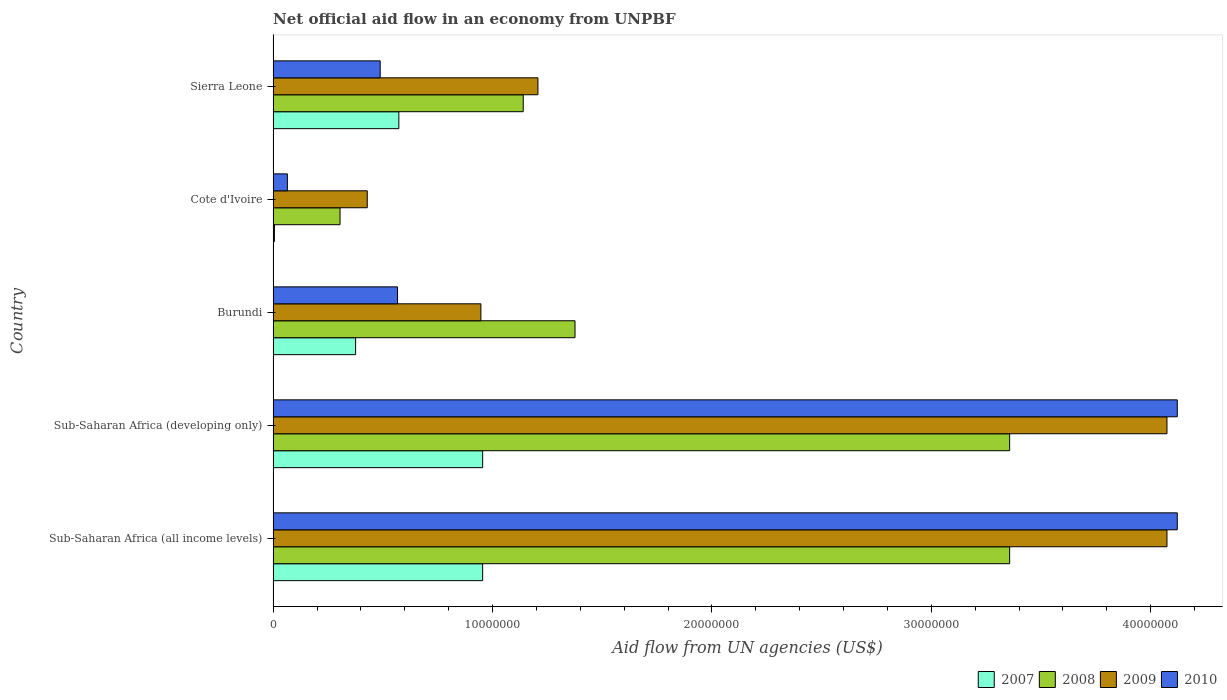How many different coloured bars are there?
Make the answer very short. 4. How many groups of bars are there?
Ensure brevity in your answer.  5. Are the number of bars per tick equal to the number of legend labels?
Your answer should be compact. Yes. Are the number of bars on each tick of the Y-axis equal?
Your answer should be very brief. Yes. How many bars are there on the 2nd tick from the top?
Provide a succinct answer. 4. What is the label of the 2nd group of bars from the top?
Your response must be concise. Cote d'Ivoire. What is the net official aid flow in 2008 in Sierra Leone?
Provide a succinct answer. 1.14e+07. Across all countries, what is the maximum net official aid flow in 2007?
Ensure brevity in your answer.  9.55e+06. Across all countries, what is the minimum net official aid flow in 2007?
Your answer should be compact. 6.00e+04. In which country was the net official aid flow in 2007 maximum?
Make the answer very short. Sub-Saharan Africa (all income levels). In which country was the net official aid flow in 2009 minimum?
Ensure brevity in your answer.  Cote d'Ivoire. What is the total net official aid flow in 2008 in the graph?
Keep it short and to the point. 9.54e+07. What is the difference between the net official aid flow in 2009 in Sierra Leone and that in Sub-Saharan Africa (all income levels)?
Give a very brief answer. -2.87e+07. What is the difference between the net official aid flow in 2008 in Sub-Saharan Africa (developing only) and the net official aid flow in 2009 in Cote d'Ivoire?
Make the answer very short. 2.93e+07. What is the average net official aid flow in 2010 per country?
Offer a very short reply. 1.87e+07. What is the difference between the net official aid flow in 2009 and net official aid flow in 2008 in Sub-Saharan Africa (all income levels)?
Ensure brevity in your answer.  7.17e+06. What is the ratio of the net official aid flow in 2010 in Burundi to that in Sub-Saharan Africa (all income levels)?
Offer a very short reply. 0.14. What is the difference between the highest and the lowest net official aid flow in 2009?
Offer a terse response. 3.64e+07. In how many countries, is the net official aid flow in 2009 greater than the average net official aid flow in 2009 taken over all countries?
Give a very brief answer. 2. Is the sum of the net official aid flow in 2009 in Cote d'Ivoire and Sub-Saharan Africa (developing only) greater than the maximum net official aid flow in 2008 across all countries?
Give a very brief answer. Yes. Is it the case that in every country, the sum of the net official aid flow in 2010 and net official aid flow in 2007 is greater than the sum of net official aid flow in 2009 and net official aid flow in 2008?
Your answer should be very brief. No. What does the 4th bar from the top in Sub-Saharan Africa (developing only) represents?
Your answer should be very brief. 2007. Are all the bars in the graph horizontal?
Make the answer very short. Yes. How many countries are there in the graph?
Provide a succinct answer. 5. Are the values on the major ticks of X-axis written in scientific E-notation?
Offer a terse response. No. Does the graph contain grids?
Offer a terse response. No. Where does the legend appear in the graph?
Your response must be concise. Bottom right. How are the legend labels stacked?
Offer a very short reply. Horizontal. What is the title of the graph?
Keep it short and to the point. Net official aid flow in an economy from UNPBF. Does "1964" appear as one of the legend labels in the graph?
Provide a short and direct response. No. What is the label or title of the X-axis?
Keep it short and to the point. Aid flow from UN agencies (US$). What is the Aid flow from UN agencies (US$) in 2007 in Sub-Saharan Africa (all income levels)?
Ensure brevity in your answer.  9.55e+06. What is the Aid flow from UN agencies (US$) of 2008 in Sub-Saharan Africa (all income levels)?
Ensure brevity in your answer.  3.36e+07. What is the Aid flow from UN agencies (US$) of 2009 in Sub-Saharan Africa (all income levels)?
Provide a succinct answer. 4.07e+07. What is the Aid flow from UN agencies (US$) in 2010 in Sub-Saharan Africa (all income levels)?
Make the answer very short. 4.12e+07. What is the Aid flow from UN agencies (US$) in 2007 in Sub-Saharan Africa (developing only)?
Your answer should be very brief. 9.55e+06. What is the Aid flow from UN agencies (US$) in 2008 in Sub-Saharan Africa (developing only)?
Make the answer very short. 3.36e+07. What is the Aid flow from UN agencies (US$) of 2009 in Sub-Saharan Africa (developing only)?
Keep it short and to the point. 4.07e+07. What is the Aid flow from UN agencies (US$) of 2010 in Sub-Saharan Africa (developing only)?
Provide a short and direct response. 4.12e+07. What is the Aid flow from UN agencies (US$) in 2007 in Burundi?
Give a very brief answer. 3.76e+06. What is the Aid flow from UN agencies (US$) of 2008 in Burundi?
Give a very brief answer. 1.38e+07. What is the Aid flow from UN agencies (US$) in 2009 in Burundi?
Offer a terse response. 9.47e+06. What is the Aid flow from UN agencies (US$) in 2010 in Burundi?
Keep it short and to the point. 5.67e+06. What is the Aid flow from UN agencies (US$) in 2008 in Cote d'Ivoire?
Offer a very short reply. 3.05e+06. What is the Aid flow from UN agencies (US$) of 2009 in Cote d'Ivoire?
Ensure brevity in your answer.  4.29e+06. What is the Aid flow from UN agencies (US$) in 2010 in Cote d'Ivoire?
Make the answer very short. 6.50e+05. What is the Aid flow from UN agencies (US$) of 2007 in Sierra Leone?
Your answer should be very brief. 5.73e+06. What is the Aid flow from UN agencies (US$) in 2008 in Sierra Leone?
Give a very brief answer. 1.14e+07. What is the Aid flow from UN agencies (US$) of 2009 in Sierra Leone?
Provide a succinct answer. 1.21e+07. What is the Aid flow from UN agencies (US$) in 2010 in Sierra Leone?
Offer a terse response. 4.88e+06. Across all countries, what is the maximum Aid flow from UN agencies (US$) in 2007?
Your answer should be compact. 9.55e+06. Across all countries, what is the maximum Aid flow from UN agencies (US$) of 2008?
Give a very brief answer. 3.36e+07. Across all countries, what is the maximum Aid flow from UN agencies (US$) of 2009?
Provide a succinct answer. 4.07e+07. Across all countries, what is the maximum Aid flow from UN agencies (US$) of 2010?
Your response must be concise. 4.12e+07. Across all countries, what is the minimum Aid flow from UN agencies (US$) in 2008?
Provide a short and direct response. 3.05e+06. Across all countries, what is the minimum Aid flow from UN agencies (US$) of 2009?
Your answer should be compact. 4.29e+06. Across all countries, what is the minimum Aid flow from UN agencies (US$) of 2010?
Your answer should be compact. 6.50e+05. What is the total Aid flow from UN agencies (US$) in 2007 in the graph?
Offer a very short reply. 2.86e+07. What is the total Aid flow from UN agencies (US$) of 2008 in the graph?
Offer a terse response. 9.54e+07. What is the total Aid flow from UN agencies (US$) in 2009 in the graph?
Your response must be concise. 1.07e+08. What is the total Aid flow from UN agencies (US$) of 2010 in the graph?
Offer a terse response. 9.36e+07. What is the difference between the Aid flow from UN agencies (US$) of 2008 in Sub-Saharan Africa (all income levels) and that in Sub-Saharan Africa (developing only)?
Provide a succinct answer. 0. What is the difference between the Aid flow from UN agencies (US$) in 2009 in Sub-Saharan Africa (all income levels) and that in Sub-Saharan Africa (developing only)?
Your response must be concise. 0. What is the difference between the Aid flow from UN agencies (US$) of 2010 in Sub-Saharan Africa (all income levels) and that in Sub-Saharan Africa (developing only)?
Make the answer very short. 0. What is the difference between the Aid flow from UN agencies (US$) in 2007 in Sub-Saharan Africa (all income levels) and that in Burundi?
Offer a terse response. 5.79e+06. What is the difference between the Aid flow from UN agencies (US$) of 2008 in Sub-Saharan Africa (all income levels) and that in Burundi?
Give a very brief answer. 1.98e+07. What is the difference between the Aid flow from UN agencies (US$) in 2009 in Sub-Saharan Africa (all income levels) and that in Burundi?
Provide a short and direct response. 3.13e+07. What is the difference between the Aid flow from UN agencies (US$) of 2010 in Sub-Saharan Africa (all income levels) and that in Burundi?
Your response must be concise. 3.55e+07. What is the difference between the Aid flow from UN agencies (US$) of 2007 in Sub-Saharan Africa (all income levels) and that in Cote d'Ivoire?
Offer a terse response. 9.49e+06. What is the difference between the Aid flow from UN agencies (US$) of 2008 in Sub-Saharan Africa (all income levels) and that in Cote d'Ivoire?
Your response must be concise. 3.05e+07. What is the difference between the Aid flow from UN agencies (US$) in 2009 in Sub-Saharan Africa (all income levels) and that in Cote d'Ivoire?
Ensure brevity in your answer.  3.64e+07. What is the difference between the Aid flow from UN agencies (US$) in 2010 in Sub-Saharan Africa (all income levels) and that in Cote d'Ivoire?
Offer a very short reply. 4.06e+07. What is the difference between the Aid flow from UN agencies (US$) of 2007 in Sub-Saharan Africa (all income levels) and that in Sierra Leone?
Your answer should be very brief. 3.82e+06. What is the difference between the Aid flow from UN agencies (US$) in 2008 in Sub-Saharan Africa (all income levels) and that in Sierra Leone?
Keep it short and to the point. 2.22e+07. What is the difference between the Aid flow from UN agencies (US$) in 2009 in Sub-Saharan Africa (all income levels) and that in Sierra Leone?
Your answer should be very brief. 2.87e+07. What is the difference between the Aid flow from UN agencies (US$) in 2010 in Sub-Saharan Africa (all income levels) and that in Sierra Leone?
Offer a very short reply. 3.63e+07. What is the difference between the Aid flow from UN agencies (US$) of 2007 in Sub-Saharan Africa (developing only) and that in Burundi?
Make the answer very short. 5.79e+06. What is the difference between the Aid flow from UN agencies (US$) in 2008 in Sub-Saharan Africa (developing only) and that in Burundi?
Provide a short and direct response. 1.98e+07. What is the difference between the Aid flow from UN agencies (US$) in 2009 in Sub-Saharan Africa (developing only) and that in Burundi?
Give a very brief answer. 3.13e+07. What is the difference between the Aid flow from UN agencies (US$) in 2010 in Sub-Saharan Africa (developing only) and that in Burundi?
Make the answer very short. 3.55e+07. What is the difference between the Aid flow from UN agencies (US$) of 2007 in Sub-Saharan Africa (developing only) and that in Cote d'Ivoire?
Offer a very short reply. 9.49e+06. What is the difference between the Aid flow from UN agencies (US$) of 2008 in Sub-Saharan Africa (developing only) and that in Cote d'Ivoire?
Keep it short and to the point. 3.05e+07. What is the difference between the Aid flow from UN agencies (US$) in 2009 in Sub-Saharan Africa (developing only) and that in Cote d'Ivoire?
Your response must be concise. 3.64e+07. What is the difference between the Aid flow from UN agencies (US$) of 2010 in Sub-Saharan Africa (developing only) and that in Cote d'Ivoire?
Keep it short and to the point. 4.06e+07. What is the difference between the Aid flow from UN agencies (US$) of 2007 in Sub-Saharan Africa (developing only) and that in Sierra Leone?
Your answer should be compact. 3.82e+06. What is the difference between the Aid flow from UN agencies (US$) of 2008 in Sub-Saharan Africa (developing only) and that in Sierra Leone?
Offer a terse response. 2.22e+07. What is the difference between the Aid flow from UN agencies (US$) of 2009 in Sub-Saharan Africa (developing only) and that in Sierra Leone?
Your answer should be compact. 2.87e+07. What is the difference between the Aid flow from UN agencies (US$) in 2010 in Sub-Saharan Africa (developing only) and that in Sierra Leone?
Your answer should be very brief. 3.63e+07. What is the difference between the Aid flow from UN agencies (US$) in 2007 in Burundi and that in Cote d'Ivoire?
Make the answer very short. 3.70e+06. What is the difference between the Aid flow from UN agencies (US$) of 2008 in Burundi and that in Cote d'Ivoire?
Offer a terse response. 1.07e+07. What is the difference between the Aid flow from UN agencies (US$) of 2009 in Burundi and that in Cote d'Ivoire?
Provide a short and direct response. 5.18e+06. What is the difference between the Aid flow from UN agencies (US$) in 2010 in Burundi and that in Cote d'Ivoire?
Offer a terse response. 5.02e+06. What is the difference between the Aid flow from UN agencies (US$) of 2007 in Burundi and that in Sierra Leone?
Keep it short and to the point. -1.97e+06. What is the difference between the Aid flow from UN agencies (US$) of 2008 in Burundi and that in Sierra Leone?
Offer a very short reply. 2.36e+06. What is the difference between the Aid flow from UN agencies (US$) of 2009 in Burundi and that in Sierra Leone?
Your response must be concise. -2.60e+06. What is the difference between the Aid flow from UN agencies (US$) of 2010 in Burundi and that in Sierra Leone?
Your response must be concise. 7.90e+05. What is the difference between the Aid flow from UN agencies (US$) of 2007 in Cote d'Ivoire and that in Sierra Leone?
Your answer should be very brief. -5.67e+06. What is the difference between the Aid flow from UN agencies (US$) in 2008 in Cote d'Ivoire and that in Sierra Leone?
Your answer should be compact. -8.35e+06. What is the difference between the Aid flow from UN agencies (US$) in 2009 in Cote d'Ivoire and that in Sierra Leone?
Your answer should be very brief. -7.78e+06. What is the difference between the Aid flow from UN agencies (US$) in 2010 in Cote d'Ivoire and that in Sierra Leone?
Give a very brief answer. -4.23e+06. What is the difference between the Aid flow from UN agencies (US$) of 2007 in Sub-Saharan Africa (all income levels) and the Aid flow from UN agencies (US$) of 2008 in Sub-Saharan Africa (developing only)?
Offer a terse response. -2.40e+07. What is the difference between the Aid flow from UN agencies (US$) in 2007 in Sub-Saharan Africa (all income levels) and the Aid flow from UN agencies (US$) in 2009 in Sub-Saharan Africa (developing only)?
Keep it short and to the point. -3.12e+07. What is the difference between the Aid flow from UN agencies (US$) of 2007 in Sub-Saharan Africa (all income levels) and the Aid flow from UN agencies (US$) of 2010 in Sub-Saharan Africa (developing only)?
Give a very brief answer. -3.17e+07. What is the difference between the Aid flow from UN agencies (US$) of 2008 in Sub-Saharan Africa (all income levels) and the Aid flow from UN agencies (US$) of 2009 in Sub-Saharan Africa (developing only)?
Provide a short and direct response. -7.17e+06. What is the difference between the Aid flow from UN agencies (US$) of 2008 in Sub-Saharan Africa (all income levels) and the Aid flow from UN agencies (US$) of 2010 in Sub-Saharan Africa (developing only)?
Provide a short and direct response. -7.64e+06. What is the difference between the Aid flow from UN agencies (US$) in 2009 in Sub-Saharan Africa (all income levels) and the Aid flow from UN agencies (US$) in 2010 in Sub-Saharan Africa (developing only)?
Your response must be concise. -4.70e+05. What is the difference between the Aid flow from UN agencies (US$) of 2007 in Sub-Saharan Africa (all income levels) and the Aid flow from UN agencies (US$) of 2008 in Burundi?
Make the answer very short. -4.21e+06. What is the difference between the Aid flow from UN agencies (US$) of 2007 in Sub-Saharan Africa (all income levels) and the Aid flow from UN agencies (US$) of 2009 in Burundi?
Offer a terse response. 8.00e+04. What is the difference between the Aid flow from UN agencies (US$) in 2007 in Sub-Saharan Africa (all income levels) and the Aid flow from UN agencies (US$) in 2010 in Burundi?
Your response must be concise. 3.88e+06. What is the difference between the Aid flow from UN agencies (US$) in 2008 in Sub-Saharan Africa (all income levels) and the Aid flow from UN agencies (US$) in 2009 in Burundi?
Provide a short and direct response. 2.41e+07. What is the difference between the Aid flow from UN agencies (US$) in 2008 in Sub-Saharan Africa (all income levels) and the Aid flow from UN agencies (US$) in 2010 in Burundi?
Keep it short and to the point. 2.79e+07. What is the difference between the Aid flow from UN agencies (US$) of 2009 in Sub-Saharan Africa (all income levels) and the Aid flow from UN agencies (US$) of 2010 in Burundi?
Your answer should be very brief. 3.51e+07. What is the difference between the Aid flow from UN agencies (US$) of 2007 in Sub-Saharan Africa (all income levels) and the Aid flow from UN agencies (US$) of 2008 in Cote d'Ivoire?
Make the answer very short. 6.50e+06. What is the difference between the Aid flow from UN agencies (US$) in 2007 in Sub-Saharan Africa (all income levels) and the Aid flow from UN agencies (US$) in 2009 in Cote d'Ivoire?
Give a very brief answer. 5.26e+06. What is the difference between the Aid flow from UN agencies (US$) of 2007 in Sub-Saharan Africa (all income levels) and the Aid flow from UN agencies (US$) of 2010 in Cote d'Ivoire?
Your answer should be very brief. 8.90e+06. What is the difference between the Aid flow from UN agencies (US$) of 2008 in Sub-Saharan Africa (all income levels) and the Aid flow from UN agencies (US$) of 2009 in Cote d'Ivoire?
Your answer should be very brief. 2.93e+07. What is the difference between the Aid flow from UN agencies (US$) in 2008 in Sub-Saharan Africa (all income levels) and the Aid flow from UN agencies (US$) in 2010 in Cote d'Ivoire?
Your answer should be compact. 3.29e+07. What is the difference between the Aid flow from UN agencies (US$) in 2009 in Sub-Saharan Africa (all income levels) and the Aid flow from UN agencies (US$) in 2010 in Cote d'Ivoire?
Your response must be concise. 4.01e+07. What is the difference between the Aid flow from UN agencies (US$) of 2007 in Sub-Saharan Africa (all income levels) and the Aid flow from UN agencies (US$) of 2008 in Sierra Leone?
Provide a succinct answer. -1.85e+06. What is the difference between the Aid flow from UN agencies (US$) in 2007 in Sub-Saharan Africa (all income levels) and the Aid flow from UN agencies (US$) in 2009 in Sierra Leone?
Your response must be concise. -2.52e+06. What is the difference between the Aid flow from UN agencies (US$) in 2007 in Sub-Saharan Africa (all income levels) and the Aid flow from UN agencies (US$) in 2010 in Sierra Leone?
Make the answer very short. 4.67e+06. What is the difference between the Aid flow from UN agencies (US$) in 2008 in Sub-Saharan Africa (all income levels) and the Aid flow from UN agencies (US$) in 2009 in Sierra Leone?
Keep it short and to the point. 2.15e+07. What is the difference between the Aid flow from UN agencies (US$) of 2008 in Sub-Saharan Africa (all income levels) and the Aid flow from UN agencies (US$) of 2010 in Sierra Leone?
Offer a terse response. 2.87e+07. What is the difference between the Aid flow from UN agencies (US$) of 2009 in Sub-Saharan Africa (all income levels) and the Aid flow from UN agencies (US$) of 2010 in Sierra Leone?
Provide a short and direct response. 3.59e+07. What is the difference between the Aid flow from UN agencies (US$) of 2007 in Sub-Saharan Africa (developing only) and the Aid flow from UN agencies (US$) of 2008 in Burundi?
Ensure brevity in your answer.  -4.21e+06. What is the difference between the Aid flow from UN agencies (US$) of 2007 in Sub-Saharan Africa (developing only) and the Aid flow from UN agencies (US$) of 2010 in Burundi?
Offer a terse response. 3.88e+06. What is the difference between the Aid flow from UN agencies (US$) of 2008 in Sub-Saharan Africa (developing only) and the Aid flow from UN agencies (US$) of 2009 in Burundi?
Provide a short and direct response. 2.41e+07. What is the difference between the Aid flow from UN agencies (US$) in 2008 in Sub-Saharan Africa (developing only) and the Aid flow from UN agencies (US$) in 2010 in Burundi?
Provide a succinct answer. 2.79e+07. What is the difference between the Aid flow from UN agencies (US$) of 2009 in Sub-Saharan Africa (developing only) and the Aid flow from UN agencies (US$) of 2010 in Burundi?
Provide a short and direct response. 3.51e+07. What is the difference between the Aid flow from UN agencies (US$) in 2007 in Sub-Saharan Africa (developing only) and the Aid flow from UN agencies (US$) in 2008 in Cote d'Ivoire?
Your response must be concise. 6.50e+06. What is the difference between the Aid flow from UN agencies (US$) in 2007 in Sub-Saharan Africa (developing only) and the Aid flow from UN agencies (US$) in 2009 in Cote d'Ivoire?
Make the answer very short. 5.26e+06. What is the difference between the Aid flow from UN agencies (US$) of 2007 in Sub-Saharan Africa (developing only) and the Aid flow from UN agencies (US$) of 2010 in Cote d'Ivoire?
Your answer should be very brief. 8.90e+06. What is the difference between the Aid flow from UN agencies (US$) of 2008 in Sub-Saharan Africa (developing only) and the Aid flow from UN agencies (US$) of 2009 in Cote d'Ivoire?
Provide a succinct answer. 2.93e+07. What is the difference between the Aid flow from UN agencies (US$) in 2008 in Sub-Saharan Africa (developing only) and the Aid flow from UN agencies (US$) in 2010 in Cote d'Ivoire?
Provide a succinct answer. 3.29e+07. What is the difference between the Aid flow from UN agencies (US$) in 2009 in Sub-Saharan Africa (developing only) and the Aid flow from UN agencies (US$) in 2010 in Cote d'Ivoire?
Offer a very short reply. 4.01e+07. What is the difference between the Aid flow from UN agencies (US$) in 2007 in Sub-Saharan Africa (developing only) and the Aid flow from UN agencies (US$) in 2008 in Sierra Leone?
Offer a very short reply. -1.85e+06. What is the difference between the Aid flow from UN agencies (US$) in 2007 in Sub-Saharan Africa (developing only) and the Aid flow from UN agencies (US$) in 2009 in Sierra Leone?
Ensure brevity in your answer.  -2.52e+06. What is the difference between the Aid flow from UN agencies (US$) of 2007 in Sub-Saharan Africa (developing only) and the Aid flow from UN agencies (US$) of 2010 in Sierra Leone?
Your answer should be very brief. 4.67e+06. What is the difference between the Aid flow from UN agencies (US$) in 2008 in Sub-Saharan Africa (developing only) and the Aid flow from UN agencies (US$) in 2009 in Sierra Leone?
Your answer should be compact. 2.15e+07. What is the difference between the Aid flow from UN agencies (US$) of 2008 in Sub-Saharan Africa (developing only) and the Aid flow from UN agencies (US$) of 2010 in Sierra Leone?
Your response must be concise. 2.87e+07. What is the difference between the Aid flow from UN agencies (US$) of 2009 in Sub-Saharan Africa (developing only) and the Aid flow from UN agencies (US$) of 2010 in Sierra Leone?
Your answer should be compact. 3.59e+07. What is the difference between the Aid flow from UN agencies (US$) in 2007 in Burundi and the Aid flow from UN agencies (US$) in 2008 in Cote d'Ivoire?
Keep it short and to the point. 7.10e+05. What is the difference between the Aid flow from UN agencies (US$) of 2007 in Burundi and the Aid flow from UN agencies (US$) of 2009 in Cote d'Ivoire?
Give a very brief answer. -5.30e+05. What is the difference between the Aid flow from UN agencies (US$) in 2007 in Burundi and the Aid flow from UN agencies (US$) in 2010 in Cote d'Ivoire?
Your answer should be very brief. 3.11e+06. What is the difference between the Aid flow from UN agencies (US$) in 2008 in Burundi and the Aid flow from UN agencies (US$) in 2009 in Cote d'Ivoire?
Give a very brief answer. 9.47e+06. What is the difference between the Aid flow from UN agencies (US$) of 2008 in Burundi and the Aid flow from UN agencies (US$) of 2010 in Cote d'Ivoire?
Your response must be concise. 1.31e+07. What is the difference between the Aid flow from UN agencies (US$) of 2009 in Burundi and the Aid flow from UN agencies (US$) of 2010 in Cote d'Ivoire?
Make the answer very short. 8.82e+06. What is the difference between the Aid flow from UN agencies (US$) of 2007 in Burundi and the Aid flow from UN agencies (US$) of 2008 in Sierra Leone?
Provide a succinct answer. -7.64e+06. What is the difference between the Aid flow from UN agencies (US$) of 2007 in Burundi and the Aid flow from UN agencies (US$) of 2009 in Sierra Leone?
Keep it short and to the point. -8.31e+06. What is the difference between the Aid flow from UN agencies (US$) in 2007 in Burundi and the Aid flow from UN agencies (US$) in 2010 in Sierra Leone?
Provide a succinct answer. -1.12e+06. What is the difference between the Aid flow from UN agencies (US$) of 2008 in Burundi and the Aid flow from UN agencies (US$) of 2009 in Sierra Leone?
Your response must be concise. 1.69e+06. What is the difference between the Aid flow from UN agencies (US$) of 2008 in Burundi and the Aid flow from UN agencies (US$) of 2010 in Sierra Leone?
Keep it short and to the point. 8.88e+06. What is the difference between the Aid flow from UN agencies (US$) of 2009 in Burundi and the Aid flow from UN agencies (US$) of 2010 in Sierra Leone?
Keep it short and to the point. 4.59e+06. What is the difference between the Aid flow from UN agencies (US$) in 2007 in Cote d'Ivoire and the Aid flow from UN agencies (US$) in 2008 in Sierra Leone?
Keep it short and to the point. -1.13e+07. What is the difference between the Aid flow from UN agencies (US$) in 2007 in Cote d'Ivoire and the Aid flow from UN agencies (US$) in 2009 in Sierra Leone?
Keep it short and to the point. -1.20e+07. What is the difference between the Aid flow from UN agencies (US$) in 2007 in Cote d'Ivoire and the Aid flow from UN agencies (US$) in 2010 in Sierra Leone?
Your answer should be very brief. -4.82e+06. What is the difference between the Aid flow from UN agencies (US$) of 2008 in Cote d'Ivoire and the Aid flow from UN agencies (US$) of 2009 in Sierra Leone?
Your answer should be compact. -9.02e+06. What is the difference between the Aid flow from UN agencies (US$) in 2008 in Cote d'Ivoire and the Aid flow from UN agencies (US$) in 2010 in Sierra Leone?
Your response must be concise. -1.83e+06. What is the difference between the Aid flow from UN agencies (US$) in 2009 in Cote d'Ivoire and the Aid flow from UN agencies (US$) in 2010 in Sierra Leone?
Your answer should be compact. -5.90e+05. What is the average Aid flow from UN agencies (US$) of 2007 per country?
Offer a terse response. 5.73e+06. What is the average Aid flow from UN agencies (US$) of 2008 per country?
Offer a very short reply. 1.91e+07. What is the average Aid flow from UN agencies (US$) of 2009 per country?
Your response must be concise. 2.15e+07. What is the average Aid flow from UN agencies (US$) of 2010 per country?
Make the answer very short. 1.87e+07. What is the difference between the Aid flow from UN agencies (US$) of 2007 and Aid flow from UN agencies (US$) of 2008 in Sub-Saharan Africa (all income levels)?
Provide a succinct answer. -2.40e+07. What is the difference between the Aid flow from UN agencies (US$) of 2007 and Aid flow from UN agencies (US$) of 2009 in Sub-Saharan Africa (all income levels)?
Give a very brief answer. -3.12e+07. What is the difference between the Aid flow from UN agencies (US$) of 2007 and Aid flow from UN agencies (US$) of 2010 in Sub-Saharan Africa (all income levels)?
Offer a terse response. -3.17e+07. What is the difference between the Aid flow from UN agencies (US$) of 2008 and Aid flow from UN agencies (US$) of 2009 in Sub-Saharan Africa (all income levels)?
Keep it short and to the point. -7.17e+06. What is the difference between the Aid flow from UN agencies (US$) in 2008 and Aid flow from UN agencies (US$) in 2010 in Sub-Saharan Africa (all income levels)?
Your response must be concise. -7.64e+06. What is the difference between the Aid flow from UN agencies (US$) in 2009 and Aid flow from UN agencies (US$) in 2010 in Sub-Saharan Africa (all income levels)?
Offer a terse response. -4.70e+05. What is the difference between the Aid flow from UN agencies (US$) of 2007 and Aid flow from UN agencies (US$) of 2008 in Sub-Saharan Africa (developing only)?
Your answer should be very brief. -2.40e+07. What is the difference between the Aid flow from UN agencies (US$) in 2007 and Aid flow from UN agencies (US$) in 2009 in Sub-Saharan Africa (developing only)?
Your answer should be compact. -3.12e+07. What is the difference between the Aid flow from UN agencies (US$) in 2007 and Aid flow from UN agencies (US$) in 2010 in Sub-Saharan Africa (developing only)?
Offer a very short reply. -3.17e+07. What is the difference between the Aid flow from UN agencies (US$) in 2008 and Aid flow from UN agencies (US$) in 2009 in Sub-Saharan Africa (developing only)?
Offer a terse response. -7.17e+06. What is the difference between the Aid flow from UN agencies (US$) in 2008 and Aid flow from UN agencies (US$) in 2010 in Sub-Saharan Africa (developing only)?
Make the answer very short. -7.64e+06. What is the difference between the Aid flow from UN agencies (US$) of 2009 and Aid flow from UN agencies (US$) of 2010 in Sub-Saharan Africa (developing only)?
Keep it short and to the point. -4.70e+05. What is the difference between the Aid flow from UN agencies (US$) of 2007 and Aid flow from UN agencies (US$) of 2008 in Burundi?
Offer a very short reply. -1.00e+07. What is the difference between the Aid flow from UN agencies (US$) in 2007 and Aid flow from UN agencies (US$) in 2009 in Burundi?
Offer a very short reply. -5.71e+06. What is the difference between the Aid flow from UN agencies (US$) of 2007 and Aid flow from UN agencies (US$) of 2010 in Burundi?
Your response must be concise. -1.91e+06. What is the difference between the Aid flow from UN agencies (US$) in 2008 and Aid flow from UN agencies (US$) in 2009 in Burundi?
Make the answer very short. 4.29e+06. What is the difference between the Aid flow from UN agencies (US$) of 2008 and Aid flow from UN agencies (US$) of 2010 in Burundi?
Your response must be concise. 8.09e+06. What is the difference between the Aid flow from UN agencies (US$) of 2009 and Aid flow from UN agencies (US$) of 2010 in Burundi?
Keep it short and to the point. 3.80e+06. What is the difference between the Aid flow from UN agencies (US$) of 2007 and Aid flow from UN agencies (US$) of 2008 in Cote d'Ivoire?
Ensure brevity in your answer.  -2.99e+06. What is the difference between the Aid flow from UN agencies (US$) in 2007 and Aid flow from UN agencies (US$) in 2009 in Cote d'Ivoire?
Make the answer very short. -4.23e+06. What is the difference between the Aid flow from UN agencies (US$) in 2007 and Aid flow from UN agencies (US$) in 2010 in Cote d'Ivoire?
Offer a terse response. -5.90e+05. What is the difference between the Aid flow from UN agencies (US$) in 2008 and Aid flow from UN agencies (US$) in 2009 in Cote d'Ivoire?
Keep it short and to the point. -1.24e+06. What is the difference between the Aid flow from UN agencies (US$) of 2008 and Aid flow from UN agencies (US$) of 2010 in Cote d'Ivoire?
Keep it short and to the point. 2.40e+06. What is the difference between the Aid flow from UN agencies (US$) in 2009 and Aid flow from UN agencies (US$) in 2010 in Cote d'Ivoire?
Provide a succinct answer. 3.64e+06. What is the difference between the Aid flow from UN agencies (US$) in 2007 and Aid flow from UN agencies (US$) in 2008 in Sierra Leone?
Your answer should be very brief. -5.67e+06. What is the difference between the Aid flow from UN agencies (US$) in 2007 and Aid flow from UN agencies (US$) in 2009 in Sierra Leone?
Make the answer very short. -6.34e+06. What is the difference between the Aid flow from UN agencies (US$) of 2007 and Aid flow from UN agencies (US$) of 2010 in Sierra Leone?
Provide a succinct answer. 8.50e+05. What is the difference between the Aid flow from UN agencies (US$) of 2008 and Aid flow from UN agencies (US$) of 2009 in Sierra Leone?
Your response must be concise. -6.70e+05. What is the difference between the Aid flow from UN agencies (US$) in 2008 and Aid flow from UN agencies (US$) in 2010 in Sierra Leone?
Provide a succinct answer. 6.52e+06. What is the difference between the Aid flow from UN agencies (US$) in 2009 and Aid flow from UN agencies (US$) in 2010 in Sierra Leone?
Your answer should be compact. 7.19e+06. What is the ratio of the Aid flow from UN agencies (US$) of 2007 in Sub-Saharan Africa (all income levels) to that in Sub-Saharan Africa (developing only)?
Your answer should be compact. 1. What is the ratio of the Aid flow from UN agencies (US$) of 2009 in Sub-Saharan Africa (all income levels) to that in Sub-Saharan Africa (developing only)?
Give a very brief answer. 1. What is the ratio of the Aid flow from UN agencies (US$) of 2010 in Sub-Saharan Africa (all income levels) to that in Sub-Saharan Africa (developing only)?
Make the answer very short. 1. What is the ratio of the Aid flow from UN agencies (US$) in 2007 in Sub-Saharan Africa (all income levels) to that in Burundi?
Give a very brief answer. 2.54. What is the ratio of the Aid flow from UN agencies (US$) in 2008 in Sub-Saharan Africa (all income levels) to that in Burundi?
Your response must be concise. 2.44. What is the ratio of the Aid flow from UN agencies (US$) in 2009 in Sub-Saharan Africa (all income levels) to that in Burundi?
Your response must be concise. 4.3. What is the ratio of the Aid flow from UN agencies (US$) of 2010 in Sub-Saharan Africa (all income levels) to that in Burundi?
Make the answer very short. 7.27. What is the ratio of the Aid flow from UN agencies (US$) of 2007 in Sub-Saharan Africa (all income levels) to that in Cote d'Ivoire?
Provide a short and direct response. 159.17. What is the ratio of the Aid flow from UN agencies (US$) in 2008 in Sub-Saharan Africa (all income levels) to that in Cote d'Ivoire?
Offer a terse response. 11.01. What is the ratio of the Aid flow from UN agencies (US$) of 2009 in Sub-Saharan Africa (all income levels) to that in Cote d'Ivoire?
Give a very brief answer. 9.5. What is the ratio of the Aid flow from UN agencies (US$) of 2010 in Sub-Saharan Africa (all income levels) to that in Cote d'Ivoire?
Make the answer very short. 63.4. What is the ratio of the Aid flow from UN agencies (US$) of 2008 in Sub-Saharan Africa (all income levels) to that in Sierra Leone?
Ensure brevity in your answer.  2.94. What is the ratio of the Aid flow from UN agencies (US$) in 2009 in Sub-Saharan Africa (all income levels) to that in Sierra Leone?
Provide a short and direct response. 3.38. What is the ratio of the Aid flow from UN agencies (US$) of 2010 in Sub-Saharan Africa (all income levels) to that in Sierra Leone?
Provide a short and direct response. 8.44. What is the ratio of the Aid flow from UN agencies (US$) in 2007 in Sub-Saharan Africa (developing only) to that in Burundi?
Ensure brevity in your answer.  2.54. What is the ratio of the Aid flow from UN agencies (US$) in 2008 in Sub-Saharan Africa (developing only) to that in Burundi?
Keep it short and to the point. 2.44. What is the ratio of the Aid flow from UN agencies (US$) in 2009 in Sub-Saharan Africa (developing only) to that in Burundi?
Keep it short and to the point. 4.3. What is the ratio of the Aid flow from UN agencies (US$) of 2010 in Sub-Saharan Africa (developing only) to that in Burundi?
Provide a succinct answer. 7.27. What is the ratio of the Aid flow from UN agencies (US$) in 2007 in Sub-Saharan Africa (developing only) to that in Cote d'Ivoire?
Offer a terse response. 159.17. What is the ratio of the Aid flow from UN agencies (US$) in 2008 in Sub-Saharan Africa (developing only) to that in Cote d'Ivoire?
Ensure brevity in your answer.  11.01. What is the ratio of the Aid flow from UN agencies (US$) in 2009 in Sub-Saharan Africa (developing only) to that in Cote d'Ivoire?
Give a very brief answer. 9.5. What is the ratio of the Aid flow from UN agencies (US$) in 2010 in Sub-Saharan Africa (developing only) to that in Cote d'Ivoire?
Keep it short and to the point. 63.4. What is the ratio of the Aid flow from UN agencies (US$) in 2007 in Sub-Saharan Africa (developing only) to that in Sierra Leone?
Offer a terse response. 1.67. What is the ratio of the Aid flow from UN agencies (US$) in 2008 in Sub-Saharan Africa (developing only) to that in Sierra Leone?
Offer a very short reply. 2.94. What is the ratio of the Aid flow from UN agencies (US$) in 2009 in Sub-Saharan Africa (developing only) to that in Sierra Leone?
Your answer should be compact. 3.38. What is the ratio of the Aid flow from UN agencies (US$) in 2010 in Sub-Saharan Africa (developing only) to that in Sierra Leone?
Make the answer very short. 8.44. What is the ratio of the Aid flow from UN agencies (US$) of 2007 in Burundi to that in Cote d'Ivoire?
Provide a short and direct response. 62.67. What is the ratio of the Aid flow from UN agencies (US$) in 2008 in Burundi to that in Cote d'Ivoire?
Ensure brevity in your answer.  4.51. What is the ratio of the Aid flow from UN agencies (US$) of 2009 in Burundi to that in Cote d'Ivoire?
Your response must be concise. 2.21. What is the ratio of the Aid flow from UN agencies (US$) of 2010 in Burundi to that in Cote d'Ivoire?
Offer a terse response. 8.72. What is the ratio of the Aid flow from UN agencies (US$) in 2007 in Burundi to that in Sierra Leone?
Your response must be concise. 0.66. What is the ratio of the Aid flow from UN agencies (US$) of 2008 in Burundi to that in Sierra Leone?
Offer a very short reply. 1.21. What is the ratio of the Aid flow from UN agencies (US$) of 2009 in Burundi to that in Sierra Leone?
Ensure brevity in your answer.  0.78. What is the ratio of the Aid flow from UN agencies (US$) of 2010 in Burundi to that in Sierra Leone?
Keep it short and to the point. 1.16. What is the ratio of the Aid flow from UN agencies (US$) of 2007 in Cote d'Ivoire to that in Sierra Leone?
Offer a terse response. 0.01. What is the ratio of the Aid flow from UN agencies (US$) of 2008 in Cote d'Ivoire to that in Sierra Leone?
Your answer should be very brief. 0.27. What is the ratio of the Aid flow from UN agencies (US$) of 2009 in Cote d'Ivoire to that in Sierra Leone?
Provide a short and direct response. 0.36. What is the ratio of the Aid flow from UN agencies (US$) in 2010 in Cote d'Ivoire to that in Sierra Leone?
Your answer should be compact. 0.13. What is the difference between the highest and the second highest Aid flow from UN agencies (US$) of 2007?
Your answer should be compact. 0. What is the difference between the highest and the second highest Aid flow from UN agencies (US$) in 2009?
Your answer should be very brief. 0. What is the difference between the highest and the lowest Aid flow from UN agencies (US$) in 2007?
Ensure brevity in your answer.  9.49e+06. What is the difference between the highest and the lowest Aid flow from UN agencies (US$) of 2008?
Offer a terse response. 3.05e+07. What is the difference between the highest and the lowest Aid flow from UN agencies (US$) in 2009?
Make the answer very short. 3.64e+07. What is the difference between the highest and the lowest Aid flow from UN agencies (US$) of 2010?
Your answer should be compact. 4.06e+07. 